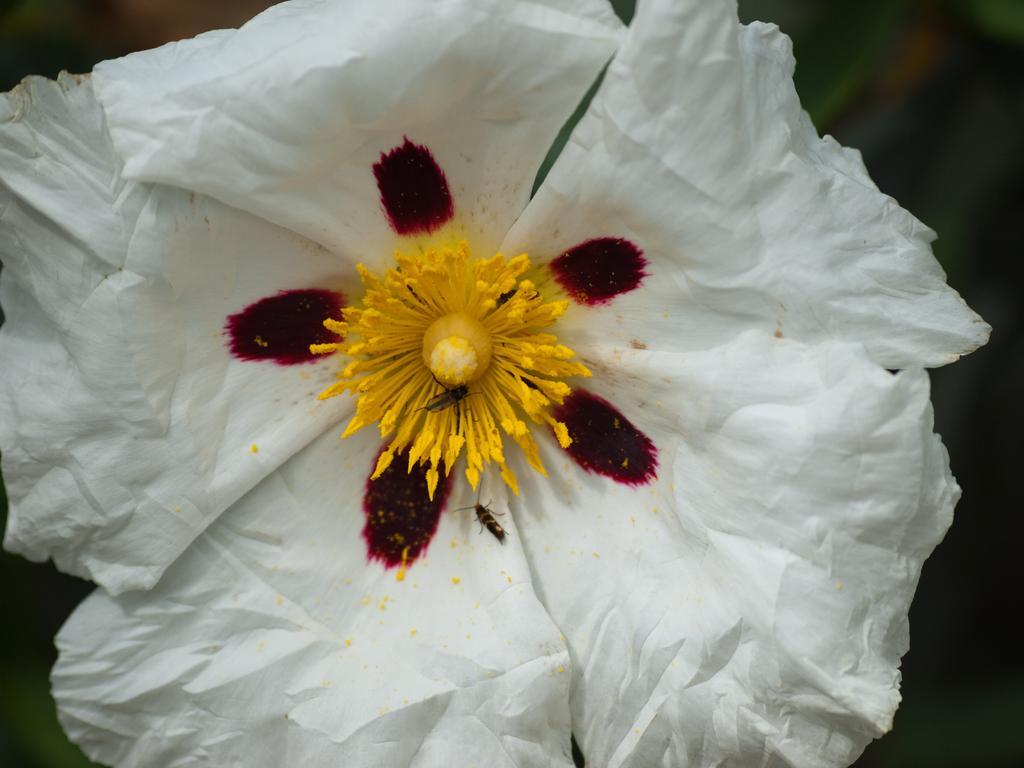Please provide a concise description of this image. The picture consists of a flower. The flower is in white color. The background is black. 